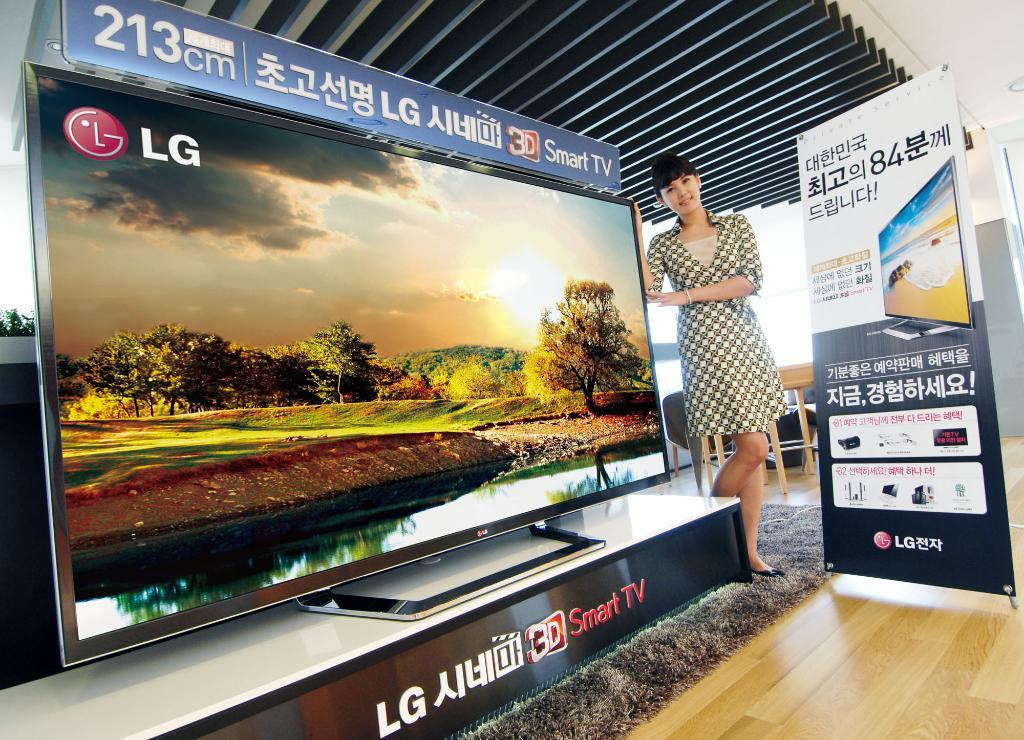<image>
Summarize the visual content of the image. An Asian woman is standing beside a very large, flat screen LG smart television. 